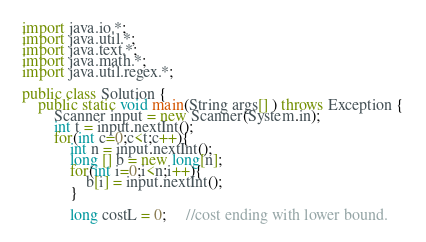Convert code to text. <code><loc_0><loc_0><loc_500><loc_500><_Java_>import java.io.*;
import java.util.*;
import java.text.*;
import java.math.*;
import java.util.regex.*;

public class Solution {
    public static void main(String args[] ) throws Exception {
        Scanner input = new Scanner(System.in);
        int t = input.nextInt();
        for(int c=0;c<t;c++){
            int n = input.nextInt();
            long [] b = new long[n];
            for(int i=0;i<n;i++){
                b[i] = input.nextInt();
            }
            
            long costL = 0;     //cost ending with lower bound.</code> 